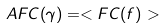<formula> <loc_0><loc_0><loc_500><loc_500>A F C ( \gamma ) = < F C ( f ) ></formula> 